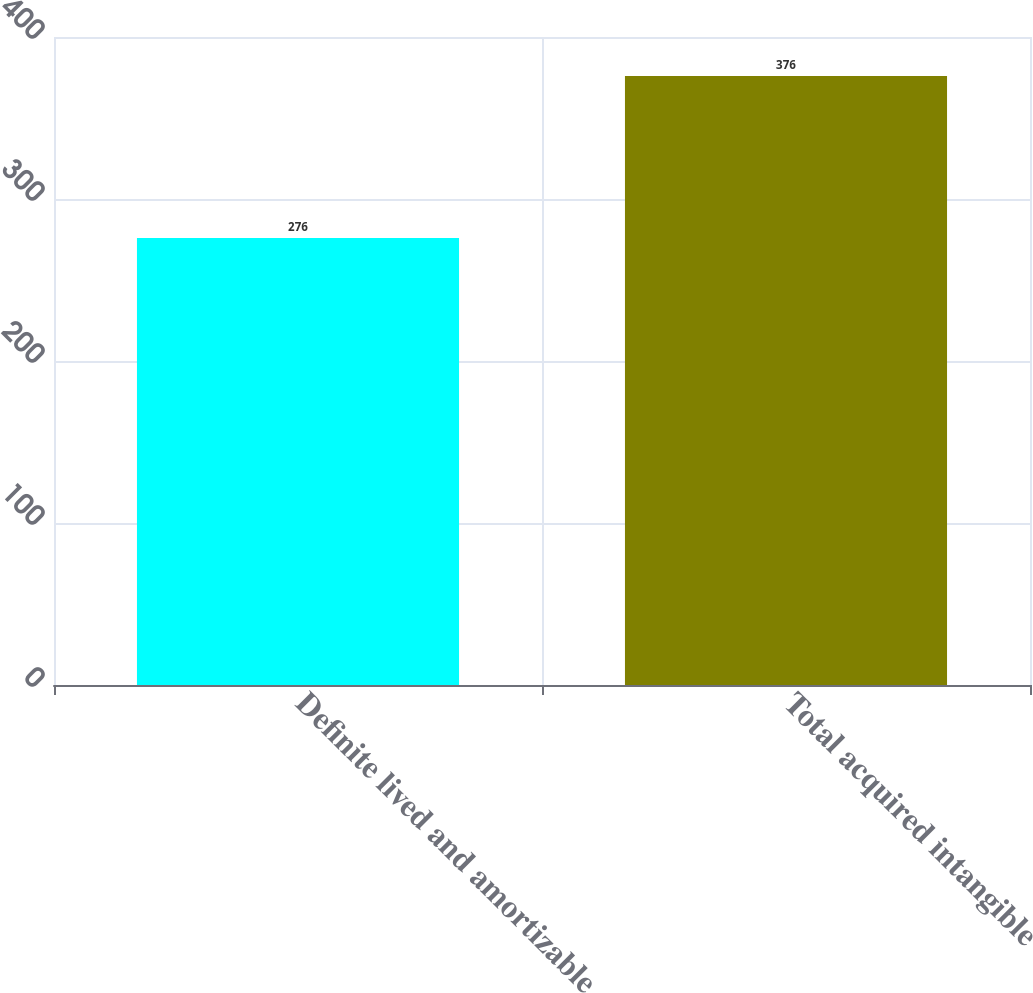<chart> <loc_0><loc_0><loc_500><loc_500><bar_chart><fcel>Definite lived and amortizable<fcel>Total acquired intangible<nl><fcel>276<fcel>376<nl></chart> 